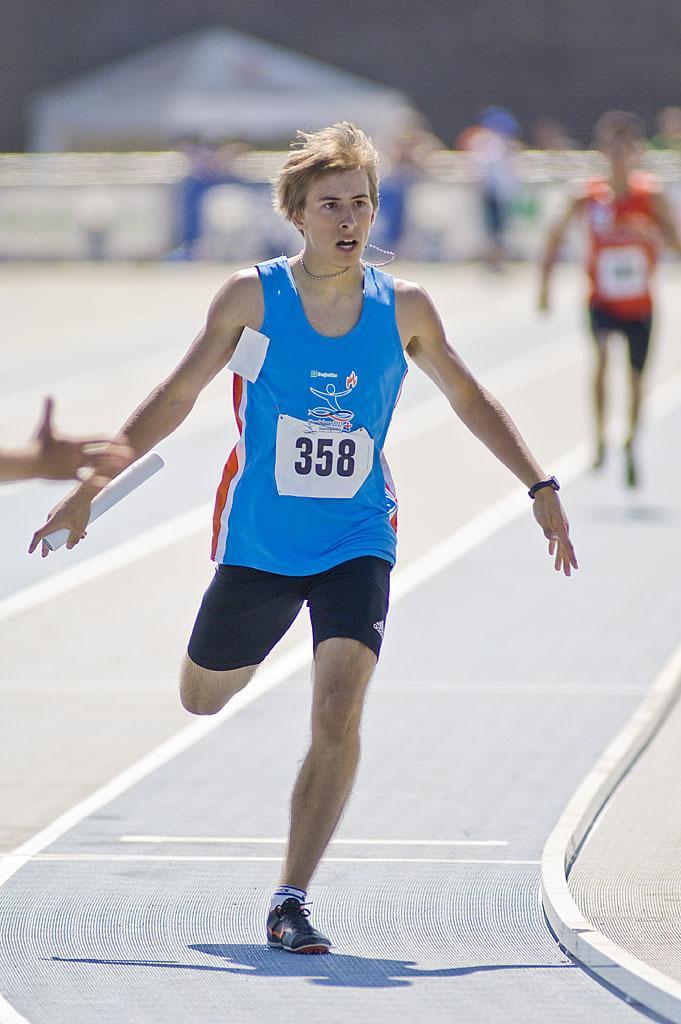Describe this image in one or two sentences. In the foreground of the picture I can see a man running on the floor and he holding the papers in his right hand. I can see the hand of a person on the left side. In the background, I can see another man running on the floor and he is on the right side. 